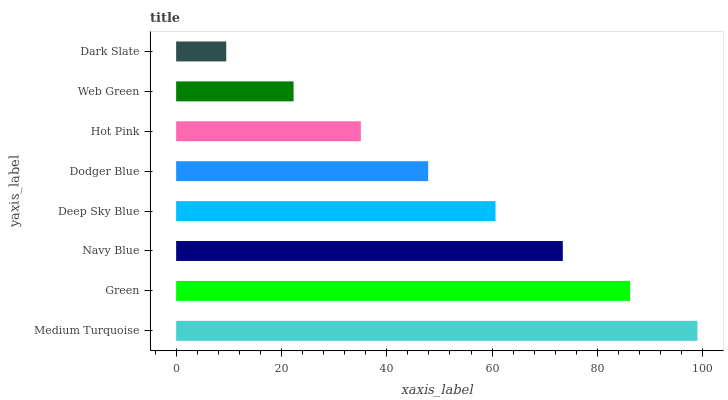Is Dark Slate the minimum?
Answer yes or no. Yes. Is Medium Turquoise the maximum?
Answer yes or no. Yes. Is Green the minimum?
Answer yes or no. No. Is Green the maximum?
Answer yes or no. No. Is Medium Turquoise greater than Green?
Answer yes or no. Yes. Is Green less than Medium Turquoise?
Answer yes or no. Yes. Is Green greater than Medium Turquoise?
Answer yes or no. No. Is Medium Turquoise less than Green?
Answer yes or no. No. Is Deep Sky Blue the high median?
Answer yes or no. Yes. Is Dodger Blue the low median?
Answer yes or no. Yes. Is Medium Turquoise the high median?
Answer yes or no. No. Is Navy Blue the low median?
Answer yes or no. No. 